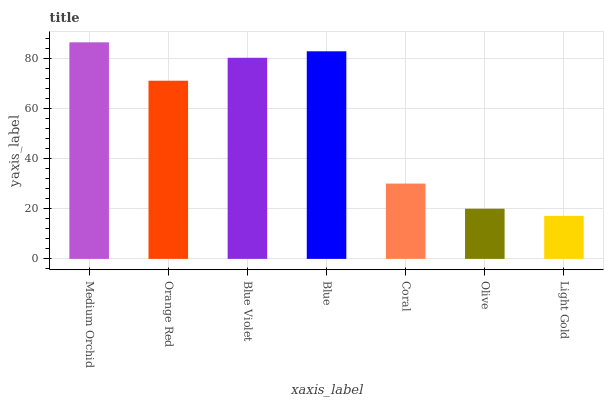Is Light Gold the minimum?
Answer yes or no. Yes. Is Medium Orchid the maximum?
Answer yes or no. Yes. Is Orange Red the minimum?
Answer yes or no. No. Is Orange Red the maximum?
Answer yes or no. No. Is Medium Orchid greater than Orange Red?
Answer yes or no. Yes. Is Orange Red less than Medium Orchid?
Answer yes or no. Yes. Is Orange Red greater than Medium Orchid?
Answer yes or no. No. Is Medium Orchid less than Orange Red?
Answer yes or no. No. Is Orange Red the high median?
Answer yes or no. Yes. Is Orange Red the low median?
Answer yes or no. Yes. Is Light Gold the high median?
Answer yes or no. No. Is Olive the low median?
Answer yes or no. No. 